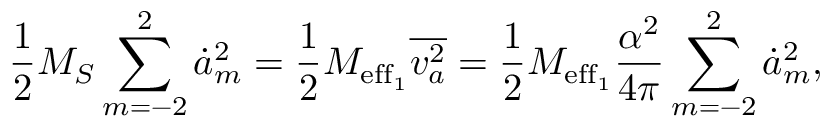Convert formula to latex. <formula><loc_0><loc_0><loc_500><loc_500>\frac { 1 } { 2 } { M _ { S } } \sum _ { m = - 2 } ^ { 2 } \dot { a } _ { m } ^ { 2 } = \frac { 1 } { 2 } M _ { e f f _ { 1 } } \overline { { v _ { a } ^ { 2 } } } = \frac { 1 } { 2 } M _ { e f f _ { 1 } } \frac { \alpha ^ { 2 } } { 4 \pi } \sum _ { m = - 2 } ^ { 2 } \dot { a } _ { m } ^ { 2 } ,</formula> 